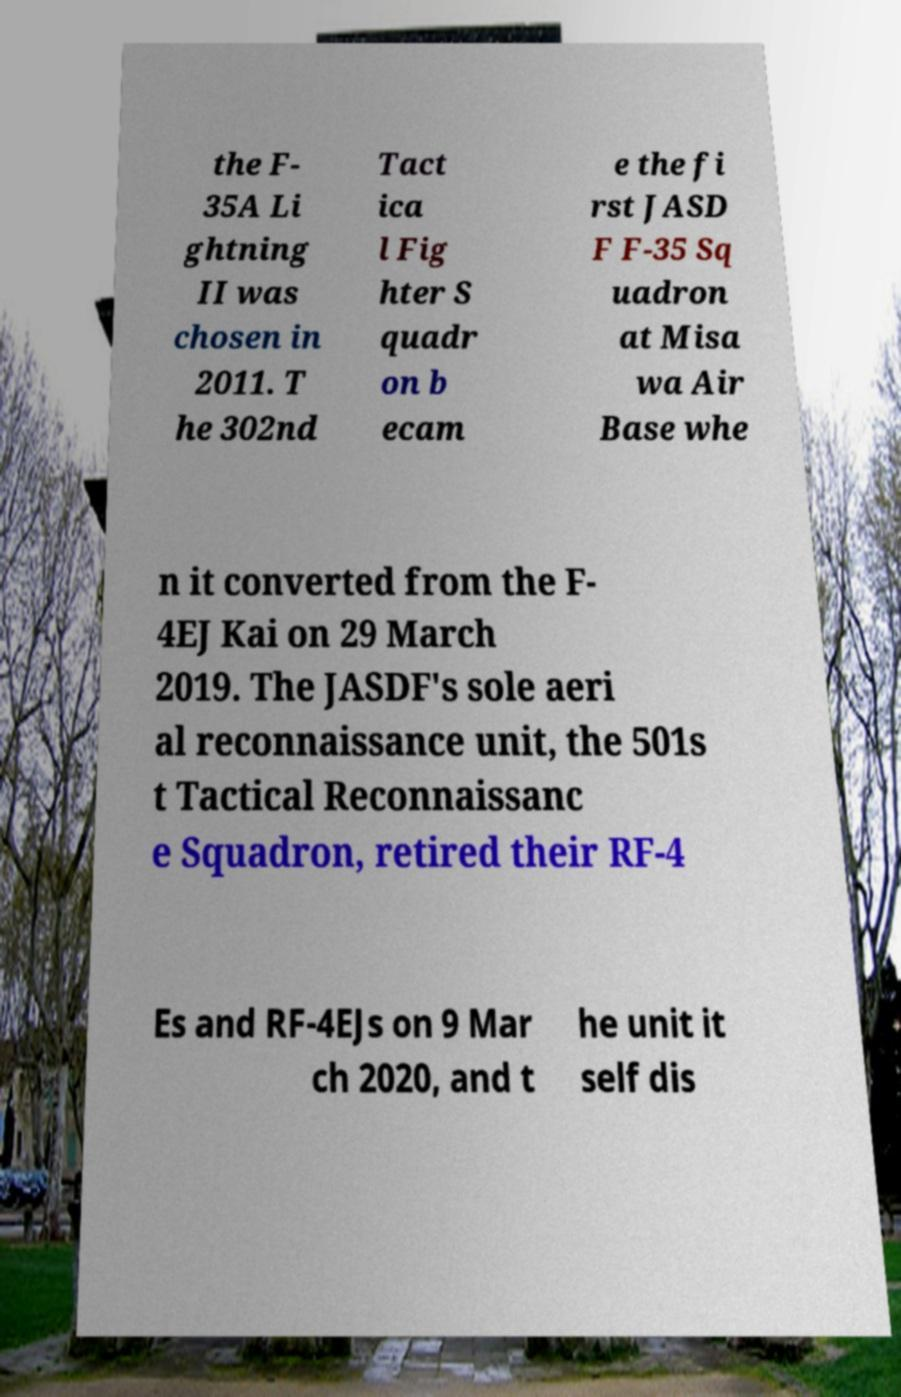I need the written content from this picture converted into text. Can you do that? the F- 35A Li ghtning II was chosen in 2011. T he 302nd Tact ica l Fig hter S quadr on b ecam e the fi rst JASD F F-35 Sq uadron at Misa wa Air Base whe n it converted from the F- 4EJ Kai on 29 March 2019. The JASDF's sole aeri al reconnaissance unit, the 501s t Tactical Reconnaissanc e Squadron, retired their RF-4 Es and RF-4EJs on 9 Mar ch 2020, and t he unit it self dis 